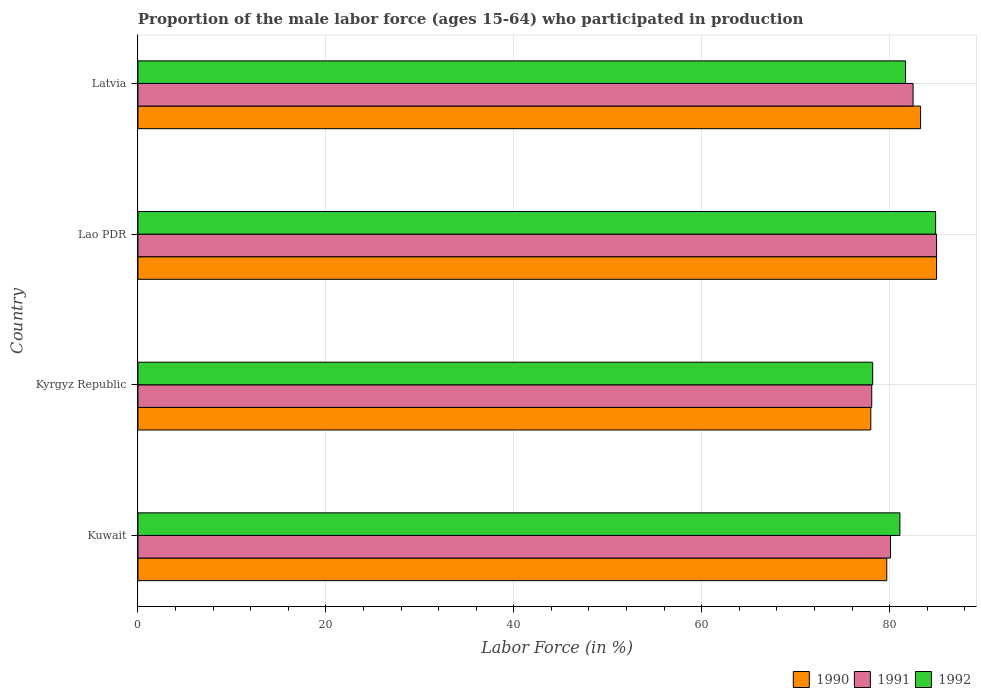How many groups of bars are there?
Give a very brief answer. 4. Are the number of bars on each tick of the Y-axis equal?
Give a very brief answer. Yes. How many bars are there on the 4th tick from the top?
Provide a succinct answer. 3. How many bars are there on the 3rd tick from the bottom?
Make the answer very short. 3. What is the label of the 2nd group of bars from the top?
Your response must be concise. Lao PDR. In how many cases, is the number of bars for a given country not equal to the number of legend labels?
Keep it short and to the point. 0. What is the proportion of the male labor force who participated in production in 1990 in Latvia?
Your answer should be very brief. 83.3. Across all countries, what is the maximum proportion of the male labor force who participated in production in 1991?
Offer a terse response. 85. Across all countries, what is the minimum proportion of the male labor force who participated in production in 1992?
Your answer should be very brief. 78.2. In which country was the proportion of the male labor force who participated in production in 1992 maximum?
Keep it short and to the point. Lao PDR. In which country was the proportion of the male labor force who participated in production in 1991 minimum?
Your response must be concise. Kyrgyz Republic. What is the total proportion of the male labor force who participated in production in 1992 in the graph?
Ensure brevity in your answer.  325.9. What is the difference between the proportion of the male labor force who participated in production in 1992 in Kyrgyz Republic and that in Latvia?
Offer a very short reply. -3.5. What is the difference between the proportion of the male labor force who participated in production in 1992 in Kyrgyz Republic and the proportion of the male labor force who participated in production in 1991 in Latvia?
Provide a succinct answer. -4.3. What is the average proportion of the male labor force who participated in production in 1991 per country?
Your response must be concise. 81.42. What is the difference between the proportion of the male labor force who participated in production in 1991 and proportion of the male labor force who participated in production in 1990 in Kuwait?
Ensure brevity in your answer.  0.4. In how many countries, is the proportion of the male labor force who participated in production in 1992 greater than 12 %?
Make the answer very short. 4. What is the ratio of the proportion of the male labor force who participated in production in 1992 in Kuwait to that in Lao PDR?
Make the answer very short. 0.96. What is the difference between the highest and the second highest proportion of the male labor force who participated in production in 1990?
Offer a terse response. 1.7. In how many countries, is the proportion of the male labor force who participated in production in 1990 greater than the average proportion of the male labor force who participated in production in 1990 taken over all countries?
Offer a terse response. 2. Is the sum of the proportion of the male labor force who participated in production in 1990 in Kuwait and Lao PDR greater than the maximum proportion of the male labor force who participated in production in 1991 across all countries?
Your response must be concise. Yes. What does the 2nd bar from the top in Latvia represents?
Provide a short and direct response. 1991. What does the 3rd bar from the bottom in Latvia represents?
Your response must be concise. 1992. Are all the bars in the graph horizontal?
Your answer should be compact. Yes. What is the difference between two consecutive major ticks on the X-axis?
Make the answer very short. 20. Are the values on the major ticks of X-axis written in scientific E-notation?
Your answer should be very brief. No. Does the graph contain any zero values?
Make the answer very short. No. Does the graph contain grids?
Provide a succinct answer. Yes. Where does the legend appear in the graph?
Provide a short and direct response. Bottom right. How are the legend labels stacked?
Provide a succinct answer. Horizontal. What is the title of the graph?
Your answer should be very brief. Proportion of the male labor force (ages 15-64) who participated in production. Does "2013" appear as one of the legend labels in the graph?
Offer a very short reply. No. What is the Labor Force (in %) of 1990 in Kuwait?
Offer a terse response. 79.7. What is the Labor Force (in %) of 1991 in Kuwait?
Your answer should be compact. 80.1. What is the Labor Force (in %) of 1992 in Kuwait?
Give a very brief answer. 81.1. What is the Labor Force (in %) of 1990 in Kyrgyz Republic?
Offer a very short reply. 78. What is the Labor Force (in %) of 1991 in Kyrgyz Republic?
Your response must be concise. 78.1. What is the Labor Force (in %) of 1992 in Kyrgyz Republic?
Give a very brief answer. 78.2. What is the Labor Force (in %) in 1991 in Lao PDR?
Provide a short and direct response. 85. What is the Labor Force (in %) in 1992 in Lao PDR?
Ensure brevity in your answer.  84.9. What is the Labor Force (in %) in 1990 in Latvia?
Your answer should be very brief. 83.3. What is the Labor Force (in %) of 1991 in Latvia?
Ensure brevity in your answer.  82.5. What is the Labor Force (in %) of 1992 in Latvia?
Give a very brief answer. 81.7. Across all countries, what is the maximum Labor Force (in %) of 1990?
Offer a very short reply. 85. Across all countries, what is the maximum Labor Force (in %) of 1992?
Provide a short and direct response. 84.9. Across all countries, what is the minimum Labor Force (in %) of 1990?
Your answer should be compact. 78. Across all countries, what is the minimum Labor Force (in %) of 1991?
Make the answer very short. 78.1. Across all countries, what is the minimum Labor Force (in %) of 1992?
Your answer should be very brief. 78.2. What is the total Labor Force (in %) of 1990 in the graph?
Offer a very short reply. 326. What is the total Labor Force (in %) of 1991 in the graph?
Offer a very short reply. 325.7. What is the total Labor Force (in %) in 1992 in the graph?
Offer a very short reply. 325.9. What is the difference between the Labor Force (in %) in 1991 in Kuwait and that in Kyrgyz Republic?
Your answer should be very brief. 2. What is the difference between the Labor Force (in %) of 1992 in Kuwait and that in Kyrgyz Republic?
Your response must be concise. 2.9. What is the difference between the Labor Force (in %) of 1990 in Kuwait and that in Lao PDR?
Your answer should be very brief. -5.3. What is the difference between the Labor Force (in %) of 1991 in Kuwait and that in Lao PDR?
Your response must be concise. -4.9. What is the difference between the Labor Force (in %) in 1992 in Kuwait and that in Lao PDR?
Keep it short and to the point. -3.8. What is the difference between the Labor Force (in %) in 1990 in Kuwait and that in Latvia?
Make the answer very short. -3.6. What is the difference between the Labor Force (in %) of 1991 in Kuwait and that in Latvia?
Ensure brevity in your answer.  -2.4. What is the difference between the Labor Force (in %) of 1992 in Kuwait and that in Latvia?
Your answer should be compact. -0.6. What is the difference between the Labor Force (in %) in 1990 in Kyrgyz Republic and that in Lao PDR?
Provide a short and direct response. -7. What is the difference between the Labor Force (in %) of 1991 in Kyrgyz Republic and that in Lao PDR?
Make the answer very short. -6.9. What is the difference between the Labor Force (in %) in 1992 in Kyrgyz Republic and that in Lao PDR?
Your answer should be very brief. -6.7. What is the difference between the Labor Force (in %) of 1990 in Kyrgyz Republic and that in Latvia?
Your response must be concise. -5.3. What is the difference between the Labor Force (in %) of 1992 in Kyrgyz Republic and that in Latvia?
Offer a terse response. -3.5. What is the difference between the Labor Force (in %) in 1991 in Lao PDR and that in Latvia?
Your answer should be very brief. 2.5. What is the difference between the Labor Force (in %) in 1992 in Lao PDR and that in Latvia?
Make the answer very short. 3.2. What is the difference between the Labor Force (in %) of 1990 in Kuwait and the Labor Force (in %) of 1991 in Kyrgyz Republic?
Provide a succinct answer. 1.6. What is the difference between the Labor Force (in %) of 1991 in Kuwait and the Labor Force (in %) of 1992 in Kyrgyz Republic?
Provide a short and direct response. 1.9. What is the difference between the Labor Force (in %) of 1990 in Kuwait and the Labor Force (in %) of 1991 in Lao PDR?
Ensure brevity in your answer.  -5.3. What is the difference between the Labor Force (in %) of 1990 in Kuwait and the Labor Force (in %) of 1992 in Lao PDR?
Offer a very short reply. -5.2. What is the difference between the Labor Force (in %) in 1991 in Kuwait and the Labor Force (in %) in 1992 in Lao PDR?
Give a very brief answer. -4.8. What is the difference between the Labor Force (in %) in 1990 in Kuwait and the Labor Force (in %) in 1991 in Latvia?
Offer a very short reply. -2.8. What is the difference between the Labor Force (in %) of 1990 in Kuwait and the Labor Force (in %) of 1992 in Latvia?
Your answer should be very brief. -2. What is the difference between the Labor Force (in %) in 1991 in Kuwait and the Labor Force (in %) in 1992 in Latvia?
Offer a terse response. -1.6. What is the difference between the Labor Force (in %) in 1990 in Kyrgyz Republic and the Labor Force (in %) in 1992 in Lao PDR?
Your response must be concise. -6.9. What is the difference between the Labor Force (in %) in 1991 in Kyrgyz Republic and the Labor Force (in %) in 1992 in Lao PDR?
Ensure brevity in your answer.  -6.8. What is the difference between the Labor Force (in %) of 1990 in Lao PDR and the Labor Force (in %) of 1991 in Latvia?
Provide a succinct answer. 2.5. What is the difference between the Labor Force (in %) of 1990 in Lao PDR and the Labor Force (in %) of 1992 in Latvia?
Keep it short and to the point. 3.3. What is the average Labor Force (in %) in 1990 per country?
Keep it short and to the point. 81.5. What is the average Labor Force (in %) of 1991 per country?
Offer a very short reply. 81.42. What is the average Labor Force (in %) of 1992 per country?
Provide a succinct answer. 81.47. What is the difference between the Labor Force (in %) in 1990 and Labor Force (in %) in 1991 in Kuwait?
Ensure brevity in your answer.  -0.4. What is the difference between the Labor Force (in %) of 1991 and Labor Force (in %) of 1992 in Kuwait?
Offer a very short reply. -1. What is the difference between the Labor Force (in %) in 1990 and Labor Force (in %) in 1992 in Lao PDR?
Provide a succinct answer. 0.1. What is the difference between the Labor Force (in %) of 1991 and Labor Force (in %) of 1992 in Lao PDR?
Keep it short and to the point. 0.1. What is the ratio of the Labor Force (in %) in 1990 in Kuwait to that in Kyrgyz Republic?
Provide a short and direct response. 1.02. What is the ratio of the Labor Force (in %) in 1991 in Kuwait to that in Kyrgyz Republic?
Your answer should be compact. 1.03. What is the ratio of the Labor Force (in %) of 1992 in Kuwait to that in Kyrgyz Republic?
Make the answer very short. 1.04. What is the ratio of the Labor Force (in %) of 1990 in Kuwait to that in Lao PDR?
Your answer should be compact. 0.94. What is the ratio of the Labor Force (in %) in 1991 in Kuwait to that in Lao PDR?
Provide a short and direct response. 0.94. What is the ratio of the Labor Force (in %) in 1992 in Kuwait to that in Lao PDR?
Keep it short and to the point. 0.96. What is the ratio of the Labor Force (in %) in 1990 in Kuwait to that in Latvia?
Provide a short and direct response. 0.96. What is the ratio of the Labor Force (in %) in 1991 in Kuwait to that in Latvia?
Give a very brief answer. 0.97. What is the ratio of the Labor Force (in %) of 1992 in Kuwait to that in Latvia?
Your answer should be compact. 0.99. What is the ratio of the Labor Force (in %) of 1990 in Kyrgyz Republic to that in Lao PDR?
Your response must be concise. 0.92. What is the ratio of the Labor Force (in %) of 1991 in Kyrgyz Republic to that in Lao PDR?
Provide a short and direct response. 0.92. What is the ratio of the Labor Force (in %) in 1992 in Kyrgyz Republic to that in Lao PDR?
Provide a succinct answer. 0.92. What is the ratio of the Labor Force (in %) in 1990 in Kyrgyz Republic to that in Latvia?
Give a very brief answer. 0.94. What is the ratio of the Labor Force (in %) of 1991 in Kyrgyz Republic to that in Latvia?
Keep it short and to the point. 0.95. What is the ratio of the Labor Force (in %) in 1992 in Kyrgyz Republic to that in Latvia?
Provide a succinct answer. 0.96. What is the ratio of the Labor Force (in %) in 1990 in Lao PDR to that in Latvia?
Keep it short and to the point. 1.02. What is the ratio of the Labor Force (in %) of 1991 in Lao PDR to that in Latvia?
Give a very brief answer. 1.03. What is the ratio of the Labor Force (in %) in 1992 in Lao PDR to that in Latvia?
Provide a short and direct response. 1.04. What is the difference between the highest and the second highest Labor Force (in %) of 1990?
Provide a succinct answer. 1.7. What is the difference between the highest and the second highest Labor Force (in %) of 1991?
Provide a short and direct response. 2.5. What is the difference between the highest and the second highest Labor Force (in %) in 1992?
Provide a short and direct response. 3.2. 